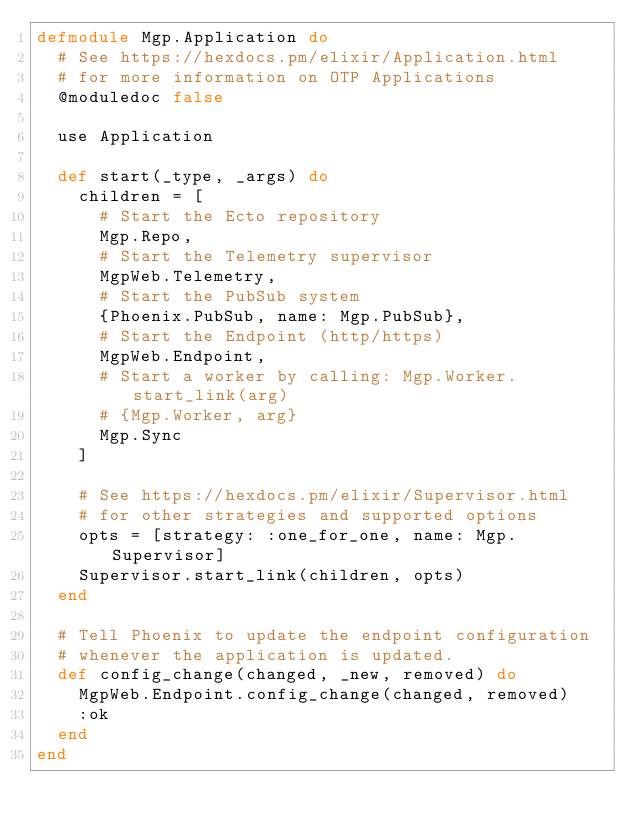<code> <loc_0><loc_0><loc_500><loc_500><_Elixir_>defmodule Mgp.Application do
  # See https://hexdocs.pm/elixir/Application.html
  # for more information on OTP Applications
  @moduledoc false

  use Application

  def start(_type, _args) do
    children = [
      # Start the Ecto repository
      Mgp.Repo,
      # Start the Telemetry supervisor
      MgpWeb.Telemetry,
      # Start the PubSub system
      {Phoenix.PubSub, name: Mgp.PubSub},
      # Start the Endpoint (http/https)
      MgpWeb.Endpoint,
      # Start a worker by calling: Mgp.Worker.start_link(arg)
      # {Mgp.Worker, arg}
      Mgp.Sync
    ]

    # See https://hexdocs.pm/elixir/Supervisor.html
    # for other strategies and supported options
    opts = [strategy: :one_for_one, name: Mgp.Supervisor]
    Supervisor.start_link(children, opts)
  end

  # Tell Phoenix to update the endpoint configuration
  # whenever the application is updated.
  def config_change(changed, _new, removed) do
    MgpWeb.Endpoint.config_change(changed, removed)
    :ok
  end
end
</code> 